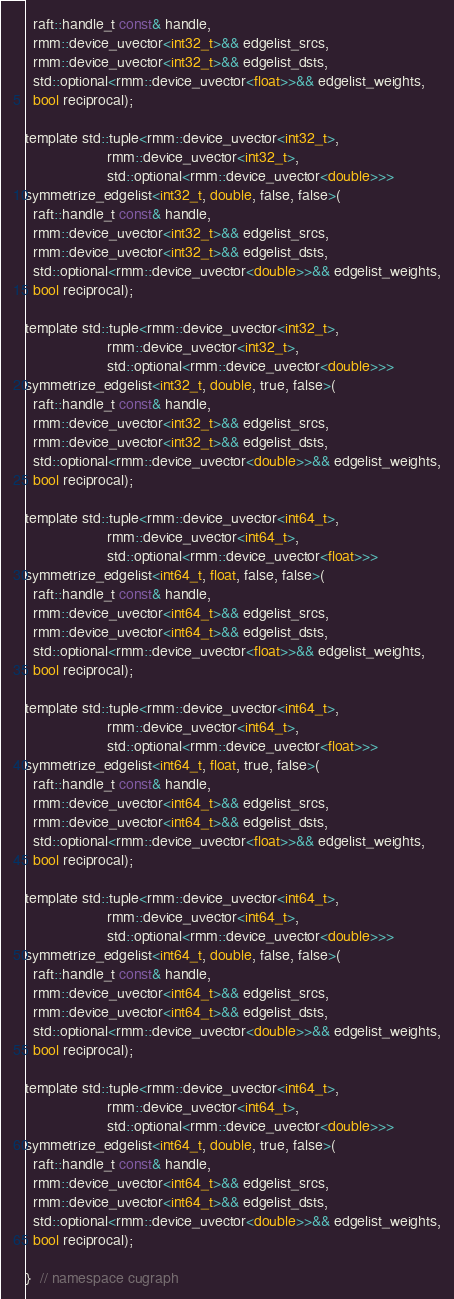<code> <loc_0><loc_0><loc_500><loc_500><_Cuda_>  raft::handle_t const& handle,
  rmm::device_uvector<int32_t>&& edgelist_srcs,
  rmm::device_uvector<int32_t>&& edgelist_dsts,
  std::optional<rmm::device_uvector<float>>&& edgelist_weights,
  bool reciprocal);

template std::tuple<rmm::device_uvector<int32_t>,
                    rmm::device_uvector<int32_t>,
                    std::optional<rmm::device_uvector<double>>>
symmetrize_edgelist<int32_t, double, false, false>(
  raft::handle_t const& handle,
  rmm::device_uvector<int32_t>&& edgelist_srcs,
  rmm::device_uvector<int32_t>&& edgelist_dsts,
  std::optional<rmm::device_uvector<double>>&& edgelist_weights,
  bool reciprocal);

template std::tuple<rmm::device_uvector<int32_t>,
                    rmm::device_uvector<int32_t>,
                    std::optional<rmm::device_uvector<double>>>
symmetrize_edgelist<int32_t, double, true, false>(
  raft::handle_t const& handle,
  rmm::device_uvector<int32_t>&& edgelist_srcs,
  rmm::device_uvector<int32_t>&& edgelist_dsts,
  std::optional<rmm::device_uvector<double>>&& edgelist_weights,
  bool reciprocal);

template std::tuple<rmm::device_uvector<int64_t>,
                    rmm::device_uvector<int64_t>,
                    std::optional<rmm::device_uvector<float>>>
symmetrize_edgelist<int64_t, float, false, false>(
  raft::handle_t const& handle,
  rmm::device_uvector<int64_t>&& edgelist_srcs,
  rmm::device_uvector<int64_t>&& edgelist_dsts,
  std::optional<rmm::device_uvector<float>>&& edgelist_weights,
  bool reciprocal);

template std::tuple<rmm::device_uvector<int64_t>,
                    rmm::device_uvector<int64_t>,
                    std::optional<rmm::device_uvector<float>>>
symmetrize_edgelist<int64_t, float, true, false>(
  raft::handle_t const& handle,
  rmm::device_uvector<int64_t>&& edgelist_srcs,
  rmm::device_uvector<int64_t>&& edgelist_dsts,
  std::optional<rmm::device_uvector<float>>&& edgelist_weights,
  bool reciprocal);

template std::tuple<rmm::device_uvector<int64_t>,
                    rmm::device_uvector<int64_t>,
                    std::optional<rmm::device_uvector<double>>>
symmetrize_edgelist<int64_t, double, false, false>(
  raft::handle_t const& handle,
  rmm::device_uvector<int64_t>&& edgelist_srcs,
  rmm::device_uvector<int64_t>&& edgelist_dsts,
  std::optional<rmm::device_uvector<double>>&& edgelist_weights,
  bool reciprocal);

template std::tuple<rmm::device_uvector<int64_t>,
                    rmm::device_uvector<int64_t>,
                    std::optional<rmm::device_uvector<double>>>
symmetrize_edgelist<int64_t, double, true, false>(
  raft::handle_t const& handle,
  rmm::device_uvector<int64_t>&& edgelist_srcs,
  rmm::device_uvector<int64_t>&& edgelist_dsts,
  std::optional<rmm::device_uvector<double>>&& edgelist_weights,
  bool reciprocal);

}  // namespace cugraph
</code> 